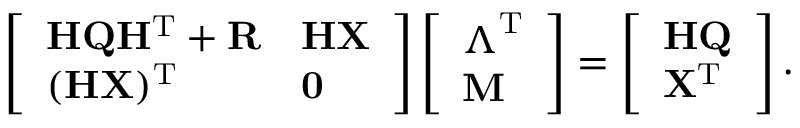Convert formula to latex. <formula><loc_0><loc_0><loc_500><loc_500>\left [ \begin{array} { l l } { H Q H ^ { T } + R } & { H X } \\ { ( H X ) ^ { T } } & { 0 } \end{array} \right ] \left [ \begin{array} { l } { \Lambda ^ { T } } \\ { M } \end{array} \right ] = \left [ \begin{array} { l } { H Q } \\ { X ^ { T } } \end{array} \right ] .</formula> 